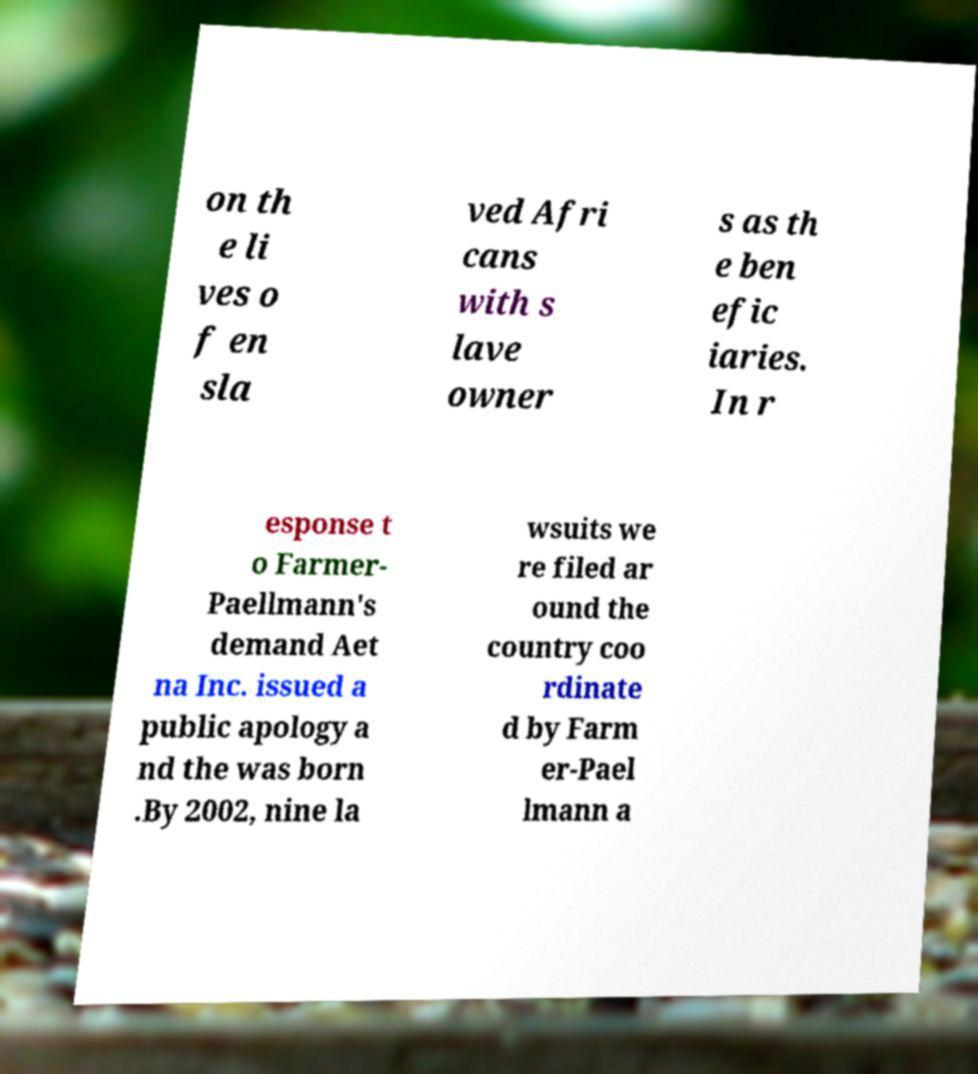For documentation purposes, I need the text within this image transcribed. Could you provide that? on th e li ves o f en sla ved Afri cans with s lave owner s as th e ben efic iaries. In r esponse t o Farmer- Paellmann's demand Aet na Inc. issued a public apology a nd the was born .By 2002, nine la wsuits we re filed ar ound the country coo rdinate d by Farm er-Pael lmann a 